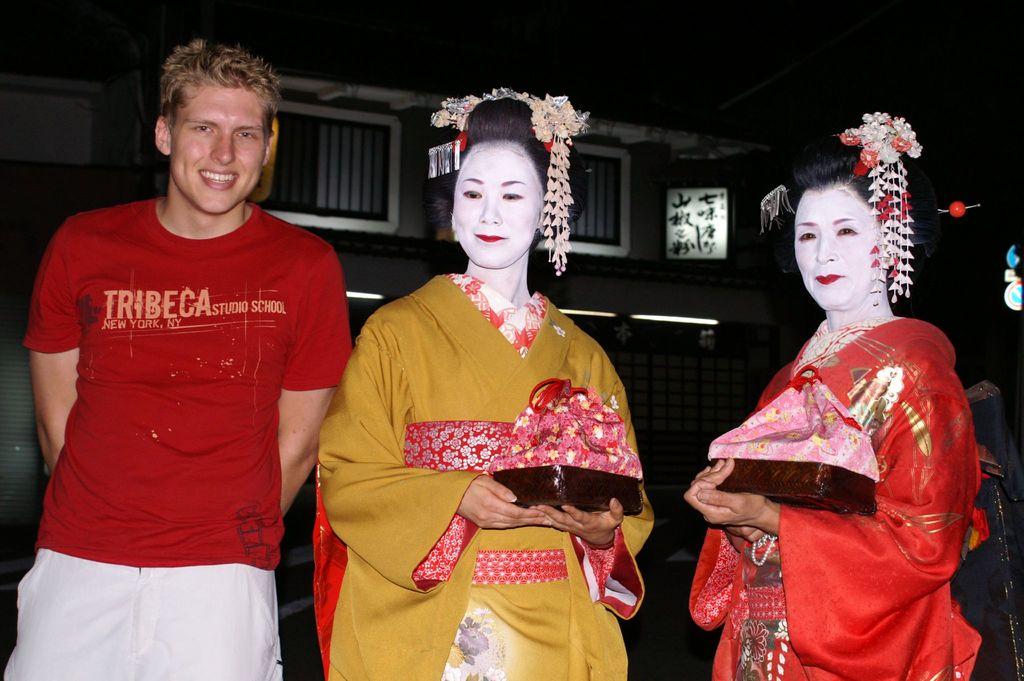What is on his shirt?
Your answer should be very brief. Tribeca. What city is the man's shirt from?
Provide a short and direct response. Tribeca. 